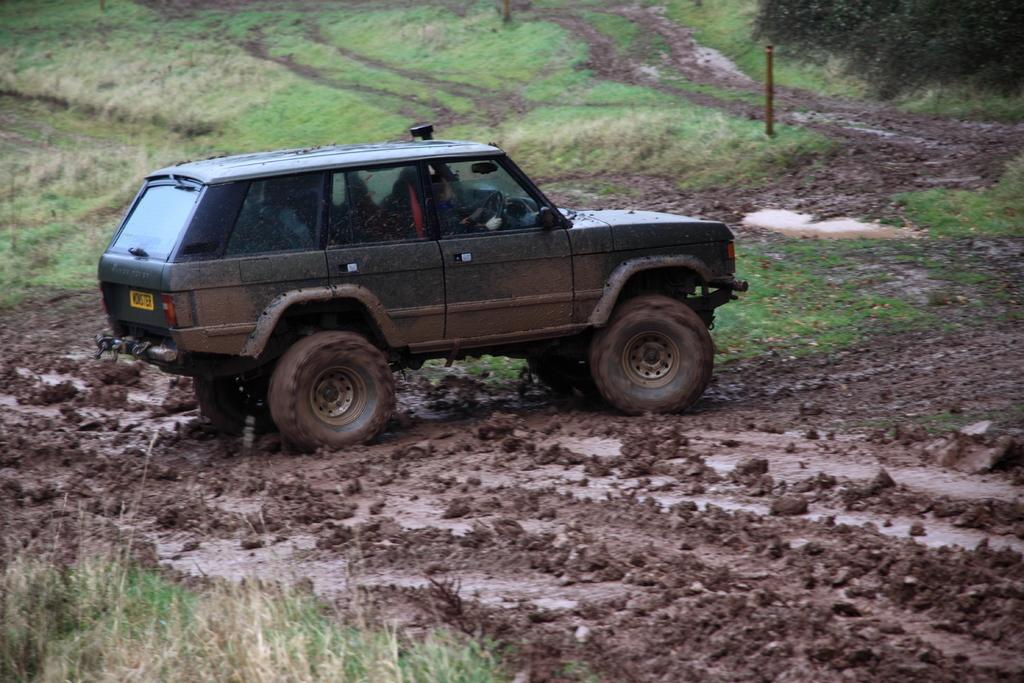What is the main subject of the image? There is a car in the image. What is the condition of the car in the image? The car is in the mud. What type of vegetation can be seen on the left side of the image? There is grass on the left side of the image. What time does the clock show in the image? There is no clock present in the image. Can you tell me the name of the minister who is standing next to the car? There is no minister or any person present in the image; it only features a car in the mud and grass on the left side. 